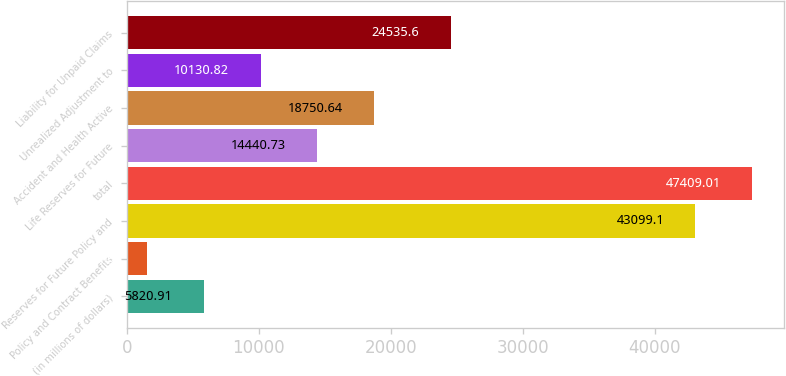Convert chart. <chart><loc_0><loc_0><loc_500><loc_500><bar_chart><fcel>(in millions of dollars)<fcel>Policy and Contract Benefits<fcel>Reserves for Future Policy and<fcel>total<fcel>Life Reserves for Future<fcel>Accident and Health Active<fcel>Unrealized Adjustment to<fcel>Liability for Unpaid Claims<nl><fcel>5820.91<fcel>1511<fcel>43099.1<fcel>47409<fcel>14440.7<fcel>18750.6<fcel>10130.8<fcel>24535.6<nl></chart> 